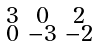<formula> <loc_0><loc_0><loc_500><loc_500>\begin{smallmatrix} 3 & 0 & 2 \\ 0 & - 3 & - 2 \end{smallmatrix}</formula> 